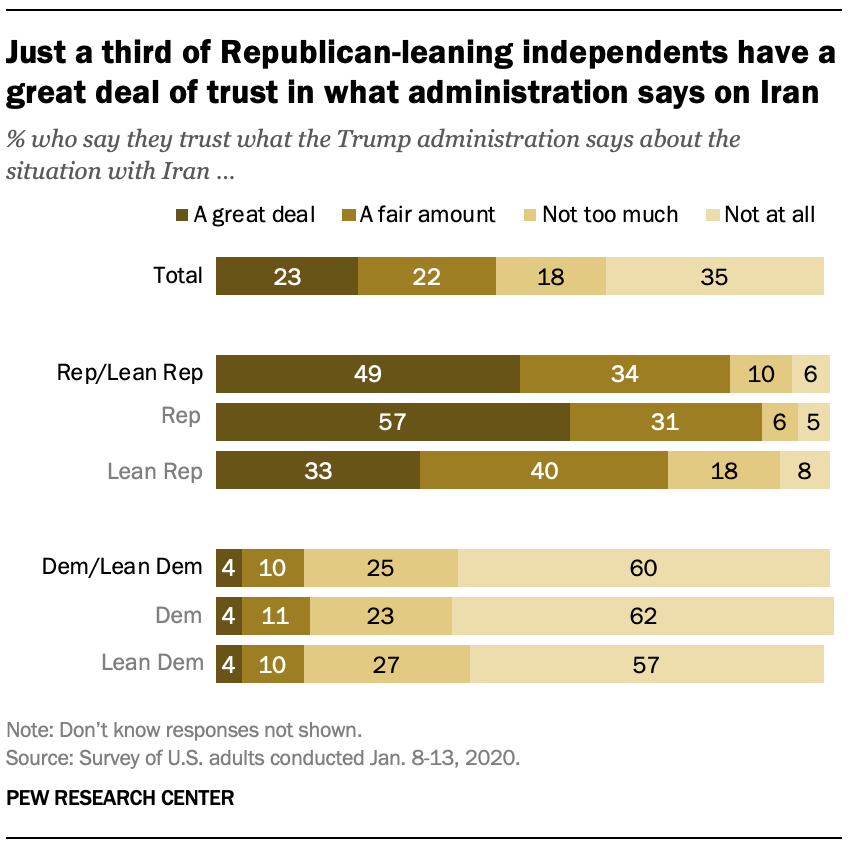Point out several critical features in this image. Out of the total number of bars, how many have values that are equal to 4, specifically 3? Four shades of brown are used to represent the graph. 